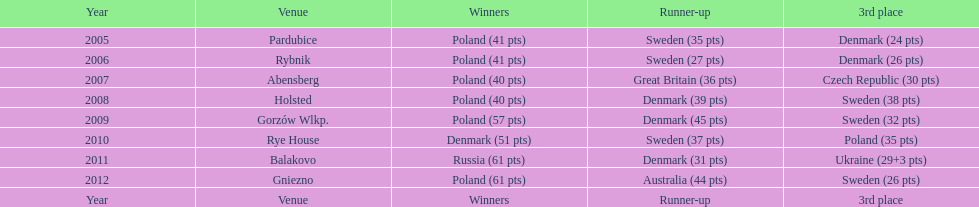What was the last year 3rd place finished with less than 25 points? 2005. Could you help me parse every detail presented in this table? {'header': ['Year', 'Venue', 'Winners', 'Runner-up', '3rd place'], 'rows': [['2005', 'Pardubice', 'Poland (41 pts)', 'Sweden (35 pts)', 'Denmark (24 pts)'], ['2006', 'Rybnik', 'Poland (41 pts)', 'Sweden (27 pts)', 'Denmark (26 pts)'], ['2007', 'Abensberg', 'Poland (40 pts)', 'Great Britain (36 pts)', 'Czech Republic (30 pts)'], ['2008', 'Holsted', 'Poland (40 pts)', 'Denmark (39 pts)', 'Sweden (38 pts)'], ['2009', 'Gorzów Wlkp.', 'Poland (57 pts)', 'Denmark (45 pts)', 'Sweden (32 pts)'], ['2010', 'Rye House', 'Denmark (51 pts)', 'Sweden (37 pts)', 'Poland (35 pts)'], ['2011', 'Balakovo', 'Russia (61 pts)', 'Denmark (31 pts)', 'Ukraine (29+3 pts)'], ['2012', 'Gniezno', 'Poland (61 pts)', 'Australia (44 pts)', 'Sweden (26 pts)'], ['Year', 'Venue', 'Winners', 'Runner-up', '3rd place']]} 